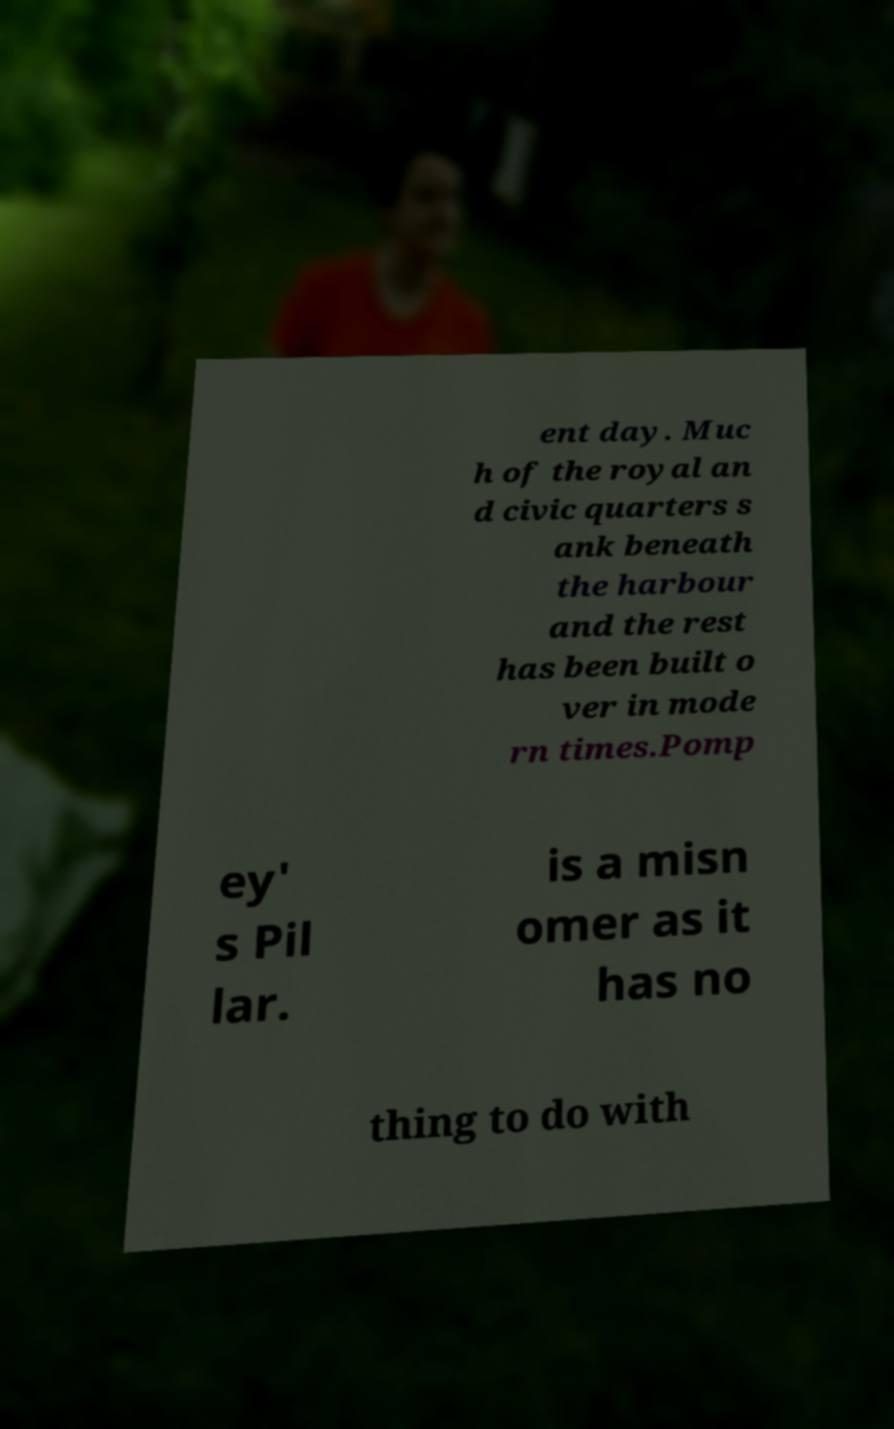Please read and relay the text visible in this image. What does it say? ent day. Muc h of the royal an d civic quarters s ank beneath the harbour and the rest has been built o ver in mode rn times.Pomp ey' s Pil lar. is a misn omer as it has no thing to do with 